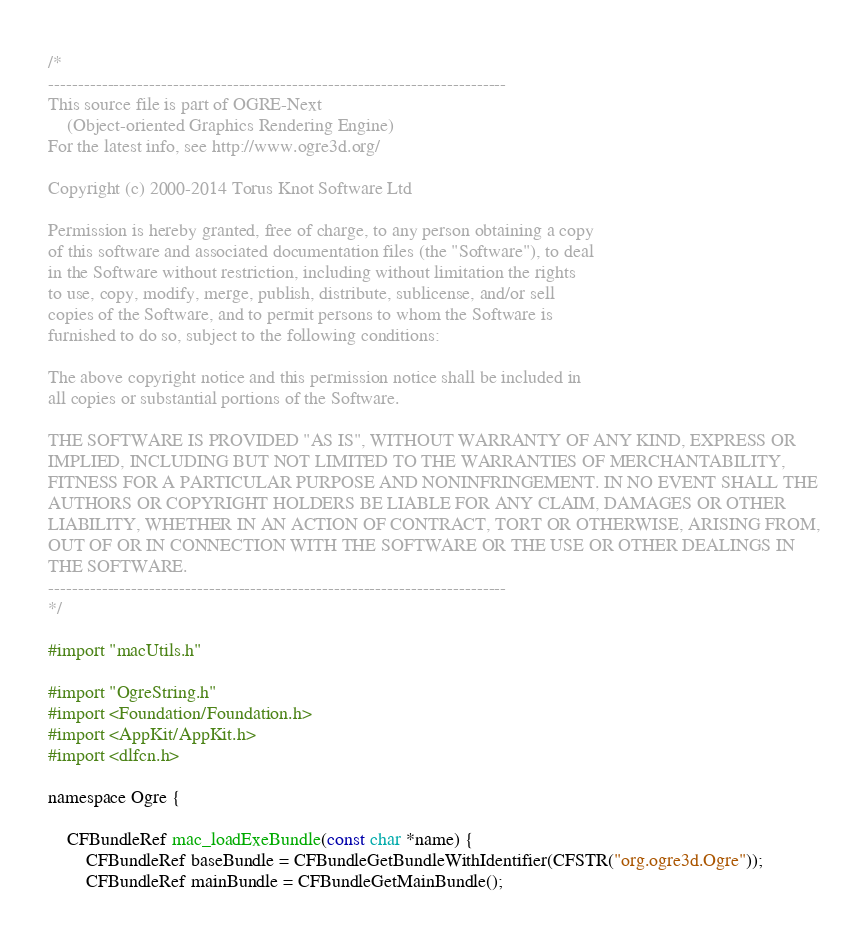Convert code to text. <code><loc_0><loc_0><loc_500><loc_500><_ObjectiveC_>/*
-----------------------------------------------------------------------------
This source file is part of OGRE-Next
    (Object-oriented Graphics Rendering Engine)
For the latest info, see http://www.ogre3d.org/

Copyright (c) 2000-2014 Torus Knot Software Ltd

Permission is hereby granted, free of charge, to any person obtaining a copy
of this software and associated documentation files (the "Software"), to deal
in the Software without restriction, including without limitation the rights
to use, copy, modify, merge, publish, distribute, sublicense, and/or sell
copies of the Software, and to permit persons to whom the Software is
furnished to do so, subject to the following conditions:

The above copyright notice and this permission notice shall be included in
all copies or substantial portions of the Software.

THE SOFTWARE IS PROVIDED "AS IS", WITHOUT WARRANTY OF ANY KIND, EXPRESS OR
IMPLIED, INCLUDING BUT NOT LIMITED TO THE WARRANTIES OF MERCHANTABILITY,
FITNESS FOR A PARTICULAR PURPOSE AND NONINFRINGEMENT. IN NO EVENT SHALL THE
AUTHORS OR COPYRIGHT HOLDERS BE LIABLE FOR ANY CLAIM, DAMAGES OR OTHER
LIABILITY, WHETHER IN AN ACTION OF CONTRACT, TORT OR OTHERWISE, ARISING FROM,
OUT OF OR IN CONNECTION WITH THE SOFTWARE OR THE USE OR OTHER DEALINGS IN
THE SOFTWARE.
-----------------------------------------------------------------------------
*/

#import "macUtils.h"

#import "OgreString.h"
#import <Foundation/Foundation.h>
#import <AppKit/AppKit.h>
#import <dlfcn.h>

namespace Ogre {

    CFBundleRef mac_loadExeBundle(const char *name) {
        CFBundleRef baseBundle = CFBundleGetBundleWithIdentifier(CFSTR("org.ogre3d.Ogre"));
        CFBundleRef mainBundle = CFBundleGetMainBundle();</code> 